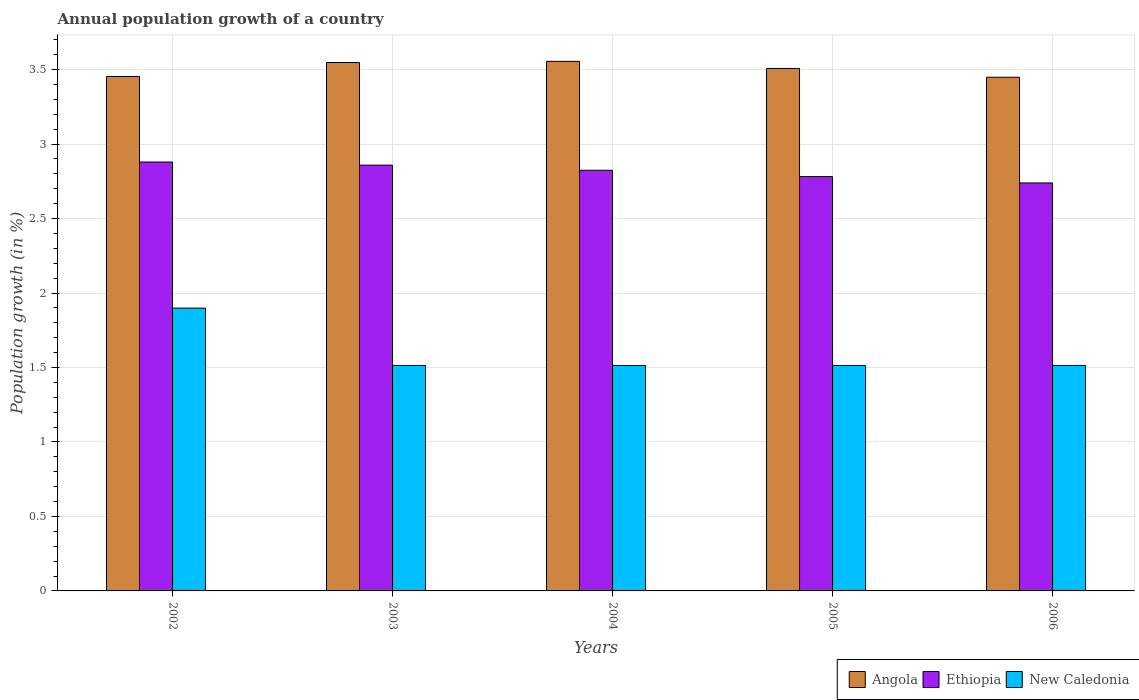Are the number of bars per tick equal to the number of legend labels?
Your answer should be compact. Yes. Are the number of bars on each tick of the X-axis equal?
Provide a short and direct response. Yes. How many bars are there on the 4th tick from the left?
Your answer should be compact. 3. How many bars are there on the 1st tick from the right?
Provide a short and direct response. 3. What is the label of the 2nd group of bars from the left?
Give a very brief answer. 2003. What is the annual population growth in Ethiopia in 2004?
Provide a succinct answer. 2.82. Across all years, what is the maximum annual population growth in New Caledonia?
Your answer should be compact. 1.9. Across all years, what is the minimum annual population growth in Angola?
Keep it short and to the point. 3.45. What is the total annual population growth in Ethiopia in the graph?
Your response must be concise. 14.08. What is the difference between the annual population growth in Ethiopia in 2003 and that in 2005?
Your answer should be compact. 0.08. What is the difference between the annual population growth in New Caledonia in 2003 and the annual population growth in Angola in 2002?
Your answer should be very brief. -1.94. What is the average annual population growth in New Caledonia per year?
Offer a terse response. 1.59. In the year 2002, what is the difference between the annual population growth in Angola and annual population growth in New Caledonia?
Your response must be concise. 1.56. In how many years, is the annual population growth in New Caledonia greater than 1.9 %?
Your response must be concise. 0. What is the ratio of the annual population growth in Ethiopia in 2004 to that in 2005?
Your answer should be very brief. 1.02. Is the difference between the annual population growth in Angola in 2002 and 2005 greater than the difference between the annual population growth in New Caledonia in 2002 and 2005?
Provide a succinct answer. No. What is the difference between the highest and the second highest annual population growth in Angola?
Provide a succinct answer. 0.01. What is the difference between the highest and the lowest annual population growth in Ethiopia?
Keep it short and to the point. 0.14. What does the 2nd bar from the left in 2003 represents?
Offer a terse response. Ethiopia. What does the 1st bar from the right in 2006 represents?
Offer a terse response. New Caledonia. Are the values on the major ticks of Y-axis written in scientific E-notation?
Give a very brief answer. No. How are the legend labels stacked?
Make the answer very short. Horizontal. What is the title of the graph?
Give a very brief answer. Annual population growth of a country. What is the label or title of the Y-axis?
Provide a succinct answer. Population growth (in %). What is the Population growth (in %) of Angola in 2002?
Ensure brevity in your answer.  3.45. What is the Population growth (in %) of Ethiopia in 2002?
Your answer should be very brief. 2.88. What is the Population growth (in %) in New Caledonia in 2002?
Offer a terse response. 1.9. What is the Population growth (in %) in Angola in 2003?
Keep it short and to the point. 3.55. What is the Population growth (in %) in Ethiopia in 2003?
Your answer should be compact. 2.86. What is the Population growth (in %) of New Caledonia in 2003?
Ensure brevity in your answer.  1.51. What is the Population growth (in %) of Angola in 2004?
Your answer should be compact. 3.56. What is the Population growth (in %) of Ethiopia in 2004?
Your answer should be very brief. 2.82. What is the Population growth (in %) of New Caledonia in 2004?
Provide a succinct answer. 1.51. What is the Population growth (in %) in Angola in 2005?
Provide a succinct answer. 3.51. What is the Population growth (in %) of Ethiopia in 2005?
Provide a short and direct response. 2.78. What is the Population growth (in %) in New Caledonia in 2005?
Provide a short and direct response. 1.51. What is the Population growth (in %) of Angola in 2006?
Your response must be concise. 3.45. What is the Population growth (in %) of Ethiopia in 2006?
Provide a short and direct response. 2.74. What is the Population growth (in %) in New Caledonia in 2006?
Provide a short and direct response. 1.51. Across all years, what is the maximum Population growth (in %) in Angola?
Your answer should be very brief. 3.56. Across all years, what is the maximum Population growth (in %) in Ethiopia?
Offer a very short reply. 2.88. Across all years, what is the maximum Population growth (in %) in New Caledonia?
Make the answer very short. 1.9. Across all years, what is the minimum Population growth (in %) in Angola?
Your answer should be very brief. 3.45. Across all years, what is the minimum Population growth (in %) in Ethiopia?
Provide a short and direct response. 2.74. Across all years, what is the minimum Population growth (in %) in New Caledonia?
Ensure brevity in your answer.  1.51. What is the total Population growth (in %) in Angola in the graph?
Make the answer very short. 17.51. What is the total Population growth (in %) of Ethiopia in the graph?
Your answer should be compact. 14.08. What is the total Population growth (in %) of New Caledonia in the graph?
Your answer should be compact. 7.95. What is the difference between the Population growth (in %) in Angola in 2002 and that in 2003?
Make the answer very short. -0.09. What is the difference between the Population growth (in %) in Ethiopia in 2002 and that in 2003?
Give a very brief answer. 0.02. What is the difference between the Population growth (in %) of New Caledonia in 2002 and that in 2003?
Your answer should be compact. 0.39. What is the difference between the Population growth (in %) of Angola in 2002 and that in 2004?
Give a very brief answer. -0.1. What is the difference between the Population growth (in %) in Ethiopia in 2002 and that in 2004?
Offer a very short reply. 0.06. What is the difference between the Population growth (in %) in New Caledonia in 2002 and that in 2004?
Offer a very short reply. 0.39. What is the difference between the Population growth (in %) of Angola in 2002 and that in 2005?
Offer a very short reply. -0.05. What is the difference between the Population growth (in %) of Ethiopia in 2002 and that in 2005?
Make the answer very short. 0.1. What is the difference between the Population growth (in %) in New Caledonia in 2002 and that in 2005?
Your response must be concise. 0.39. What is the difference between the Population growth (in %) in Angola in 2002 and that in 2006?
Your answer should be very brief. 0.01. What is the difference between the Population growth (in %) in Ethiopia in 2002 and that in 2006?
Your answer should be compact. 0.14. What is the difference between the Population growth (in %) in New Caledonia in 2002 and that in 2006?
Your answer should be compact. 0.39. What is the difference between the Population growth (in %) of Angola in 2003 and that in 2004?
Offer a terse response. -0.01. What is the difference between the Population growth (in %) of Ethiopia in 2003 and that in 2004?
Your response must be concise. 0.03. What is the difference between the Population growth (in %) in Angola in 2003 and that in 2005?
Offer a terse response. 0.04. What is the difference between the Population growth (in %) of Ethiopia in 2003 and that in 2005?
Give a very brief answer. 0.08. What is the difference between the Population growth (in %) in New Caledonia in 2003 and that in 2005?
Your response must be concise. -0. What is the difference between the Population growth (in %) of Angola in 2003 and that in 2006?
Offer a terse response. 0.1. What is the difference between the Population growth (in %) of Ethiopia in 2003 and that in 2006?
Your response must be concise. 0.12. What is the difference between the Population growth (in %) of New Caledonia in 2003 and that in 2006?
Offer a very short reply. -0. What is the difference between the Population growth (in %) in Angola in 2004 and that in 2005?
Ensure brevity in your answer.  0.05. What is the difference between the Population growth (in %) of Ethiopia in 2004 and that in 2005?
Your response must be concise. 0.04. What is the difference between the Population growth (in %) of New Caledonia in 2004 and that in 2005?
Ensure brevity in your answer.  -0. What is the difference between the Population growth (in %) of Angola in 2004 and that in 2006?
Make the answer very short. 0.11. What is the difference between the Population growth (in %) in Ethiopia in 2004 and that in 2006?
Give a very brief answer. 0.09. What is the difference between the Population growth (in %) of New Caledonia in 2004 and that in 2006?
Give a very brief answer. -0. What is the difference between the Population growth (in %) in Angola in 2005 and that in 2006?
Provide a short and direct response. 0.06. What is the difference between the Population growth (in %) in Ethiopia in 2005 and that in 2006?
Ensure brevity in your answer.  0.04. What is the difference between the Population growth (in %) in Angola in 2002 and the Population growth (in %) in Ethiopia in 2003?
Make the answer very short. 0.6. What is the difference between the Population growth (in %) of Angola in 2002 and the Population growth (in %) of New Caledonia in 2003?
Your answer should be very brief. 1.94. What is the difference between the Population growth (in %) in Ethiopia in 2002 and the Population growth (in %) in New Caledonia in 2003?
Make the answer very short. 1.37. What is the difference between the Population growth (in %) of Angola in 2002 and the Population growth (in %) of Ethiopia in 2004?
Offer a terse response. 0.63. What is the difference between the Population growth (in %) in Angola in 2002 and the Population growth (in %) in New Caledonia in 2004?
Your response must be concise. 1.94. What is the difference between the Population growth (in %) of Ethiopia in 2002 and the Population growth (in %) of New Caledonia in 2004?
Offer a very short reply. 1.37. What is the difference between the Population growth (in %) of Angola in 2002 and the Population growth (in %) of Ethiopia in 2005?
Make the answer very short. 0.67. What is the difference between the Population growth (in %) of Angola in 2002 and the Population growth (in %) of New Caledonia in 2005?
Give a very brief answer. 1.94. What is the difference between the Population growth (in %) of Ethiopia in 2002 and the Population growth (in %) of New Caledonia in 2005?
Provide a succinct answer. 1.37. What is the difference between the Population growth (in %) of Angola in 2002 and the Population growth (in %) of Ethiopia in 2006?
Your answer should be very brief. 0.71. What is the difference between the Population growth (in %) of Angola in 2002 and the Population growth (in %) of New Caledonia in 2006?
Offer a terse response. 1.94. What is the difference between the Population growth (in %) of Ethiopia in 2002 and the Population growth (in %) of New Caledonia in 2006?
Keep it short and to the point. 1.37. What is the difference between the Population growth (in %) in Angola in 2003 and the Population growth (in %) in Ethiopia in 2004?
Provide a succinct answer. 0.72. What is the difference between the Population growth (in %) of Angola in 2003 and the Population growth (in %) of New Caledonia in 2004?
Offer a terse response. 2.03. What is the difference between the Population growth (in %) of Ethiopia in 2003 and the Population growth (in %) of New Caledonia in 2004?
Make the answer very short. 1.35. What is the difference between the Population growth (in %) in Angola in 2003 and the Population growth (in %) in Ethiopia in 2005?
Your answer should be very brief. 0.77. What is the difference between the Population growth (in %) in Angola in 2003 and the Population growth (in %) in New Caledonia in 2005?
Ensure brevity in your answer.  2.03. What is the difference between the Population growth (in %) in Ethiopia in 2003 and the Population growth (in %) in New Caledonia in 2005?
Offer a very short reply. 1.34. What is the difference between the Population growth (in %) in Angola in 2003 and the Population growth (in %) in Ethiopia in 2006?
Offer a terse response. 0.81. What is the difference between the Population growth (in %) in Angola in 2003 and the Population growth (in %) in New Caledonia in 2006?
Keep it short and to the point. 2.03. What is the difference between the Population growth (in %) of Ethiopia in 2003 and the Population growth (in %) of New Caledonia in 2006?
Your answer should be very brief. 1.34. What is the difference between the Population growth (in %) in Angola in 2004 and the Population growth (in %) in Ethiopia in 2005?
Give a very brief answer. 0.77. What is the difference between the Population growth (in %) in Angola in 2004 and the Population growth (in %) in New Caledonia in 2005?
Make the answer very short. 2.04. What is the difference between the Population growth (in %) in Ethiopia in 2004 and the Population growth (in %) in New Caledonia in 2005?
Offer a very short reply. 1.31. What is the difference between the Population growth (in %) in Angola in 2004 and the Population growth (in %) in Ethiopia in 2006?
Provide a succinct answer. 0.82. What is the difference between the Population growth (in %) of Angola in 2004 and the Population growth (in %) of New Caledonia in 2006?
Provide a succinct answer. 2.04. What is the difference between the Population growth (in %) of Ethiopia in 2004 and the Population growth (in %) of New Caledonia in 2006?
Give a very brief answer. 1.31. What is the difference between the Population growth (in %) in Angola in 2005 and the Population growth (in %) in Ethiopia in 2006?
Give a very brief answer. 0.77. What is the difference between the Population growth (in %) of Angola in 2005 and the Population growth (in %) of New Caledonia in 2006?
Ensure brevity in your answer.  1.99. What is the difference between the Population growth (in %) in Ethiopia in 2005 and the Population growth (in %) in New Caledonia in 2006?
Make the answer very short. 1.27. What is the average Population growth (in %) in Angola per year?
Your answer should be very brief. 3.5. What is the average Population growth (in %) in Ethiopia per year?
Your response must be concise. 2.82. What is the average Population growth (in %) of New Caledonia per year?
Provide a succinct answer. 1.59. In the year 2002, what is the difference between the Population growth (in %) in Angola and Population growth (in %) in Ethiopia?
Make the answer very short. 0.57. In the year 2002, what is the difference between the Population growth (in %) of Angola and Population growth (in %) of New Caledonia?
Offer a terse response. 1.55. In the year 2002, what is the difference between the Population growth (in %) of Ethiopia and Population growth (in %) of New Caledonia?
Your answer should be compact. 0.98. In the year 2003, what is the difference between the Population growth (in %) in Angola and Population growth (in %) in Ethiopia?
Provide a succinct answer. 0.69. In the year 2003, what is the difference between the Population growth (in %) of Angola and Population growth (in %) of New Caledonia?
Ensure brevity in your answer.  2.03. In the year 2003, what is the difference between the Population growth (in %) in Ethiopia and Population growth (in %) in New Caledonia?
Make the answer very short. 1.34. In the year 2004, what is the difference between the Population growth (in %) of Angola and Population growth (in %) of Ethiopia?
Give a very brief answer. 0.73. In the year 2004, what is the difference between the Population growth (in %) in Angola and Population growth (in %) in New Caledonia?
Keep it short and to the point. 2.04. In the year 2004, what is the difference between the Population growth (in %) of Ethiopia and Population growth (in %) of New Caledonia?
Your response must be concise. 1.31. In the year 2005, what is the difference between the Population growth (in %) of Angola and Population growth (in %) of Ethiopia?
Your answer should be very brief. 0.73. In the year 2005, what is the difference between the Population growth (in %) of Angola and Population growth (in %) of New Caledonia?
Offer a very short reply. 1.99. In the year 2005, what is the difference between the Population growth (in %) in Ethiopia and Population growth (in %) in New Caledonia?
Your response must be concise. 1.27. In the year 2006, what is the difference between the Population growth (in %) of Angola and Population growth (in %) of Ethiopia?
Make the answer very short. 0.71. In the year 2006, what is the difference between the Population growth (in %) in Angola and Population growth (in %) in New Caledonia?
Offer a terse response. 1.94. In the year 2006, what is the difference between the Population growth (in %) in Ethiopia and Population growth (in %) in New Caledonia?
Offer a terse response. 1.23. What is the ratio of the Population growth (in %) in Angola in 2002 to that in 2003?
Keep it short and to the point. 0.97. What is the ratio of the Population growth (in %) in Ethiopia in 2002 to that in 2003?
Ensure brevity in your answer.  1.01. What is the ratio of the Population growth (in %) of New Caledonia in 2002 to that in 2003?
Make the answer very short. 1.25. What is the ratio of the Population growth (in %) of Angola in 2002 to that in 2004?
Offer a very short reply. 0.97. What is the ratio of the Population growth (in %) in Ethiopia in 2002 to that in 2004?
Provide a short and direct response. 1.02. What is the ratio of the Population growth (in %) in New Caledonia in 2002 to that in 2004?
Offer a terse response. 1.25. What is the ratio of the Population growth (in %) in Angola in 2002 to that in 2005?
Your answer should be very brief. 0.98. What is the ratio of the Population growth (in %) of Ethiopia in 2002 to that in 2005?
Provide a short and direct response. 1.04. What is the ratio of the Population growth (in %) in New Caledonia in 2002 to that in 2005?
Your answer should be very brief. 1.25. What is the ratio of the Population growth (in %) in Ethiopia in 2002 to that in 2006?
Provide a succinct answer. 1.05. What is the ratio of the Population growth (in %) of New Caledonia in 2002 to that in 2006?
Offer a terse response. 1.25. What is the ratio of the Population growth (in %) of Ethiopia in 2003 to that in 2004?
Your answer should be compact. 1.01. What is the ratio of the Population growth (in %) of Angola in 2003 to that in 2005?
Give a very brief answer. 1.01. What is the ratio of the Population growth (in %) in Ethiopia in 2003 to that in 2005?
Your answer should be compact. 1.03. What is the ratio of the Population growth (in %) of Angola in 2003 to that in 2006?
Keep it short and to the point. 1.03. What is the ratio of the Population growth (in %) of Ethiopia in 2003 to that in 2006?
Your response must be concise. 1.04. What is the ratio of the Population growth (in %) of Angola in 2004 to that in 2005?
Your answer should be very brief. 1.01. What is the ratio of the Population growth (in %) of Ethiopia in 2004 to that in 2005?
Your answer should be very brief. 1.02. What is the ratio of the Population growth (in %) of Angola in 2004 to that in 2006?
Offer a terse response. 1.03. What is the ratio of the Population growth (in %) of Ethiopia in 2004 to that in 2006?
Offer a terse response. 1.03. What is the ratio of the Population growth (in %) of Angola in 2005 to that in 2006?
Provide a succinct answer. 1.02. What is the ratio of the Population growth (in %) in Ethiopia in 2005 to that in 2006?
Provide a succinct answer. 1.02. What is the difference between the highest and the second highest Population growth (in %) of Angola?
Offer a terse response. 0.01. What is the difference between the highest and the second highest Population growth (in %) in Ethiopia?
Your response must be concise. 0.02. What is the difference between the highest and the second highest Population growth (in %) of New Caledonia?
Offer a very short reply. 0.39. What is the difference between the highest and the lowest Population growth (in %) in Angola?
Ensure brevity in your answer.  0.11. What is the difference between the highest and the lowest Population growth (in %) of Ethiopia?
Keep it short and to the point. 0.14. What is the difference between the highest and the lowest Population growth (in %) in New Caledonia?
Your answer should be compact. 0.39. 